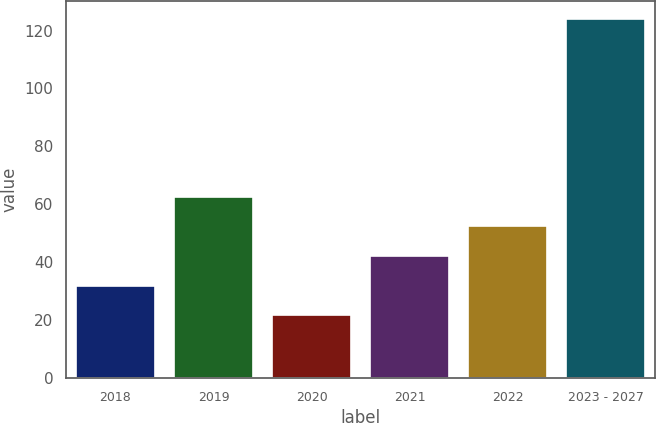Convert chart. <chart><loc_0><loc_0><loc_500><loc_500><bar_chart><fcel>2018<fcel>2019<fcel>2020<fcel>2021<fcel>2022<fcel>2023 - 2027<nl><fcel>31.84<fcel>62.56<fcel>21.6<fcel>42.08<fcel>52.32<fcel>124<nl></chart> 